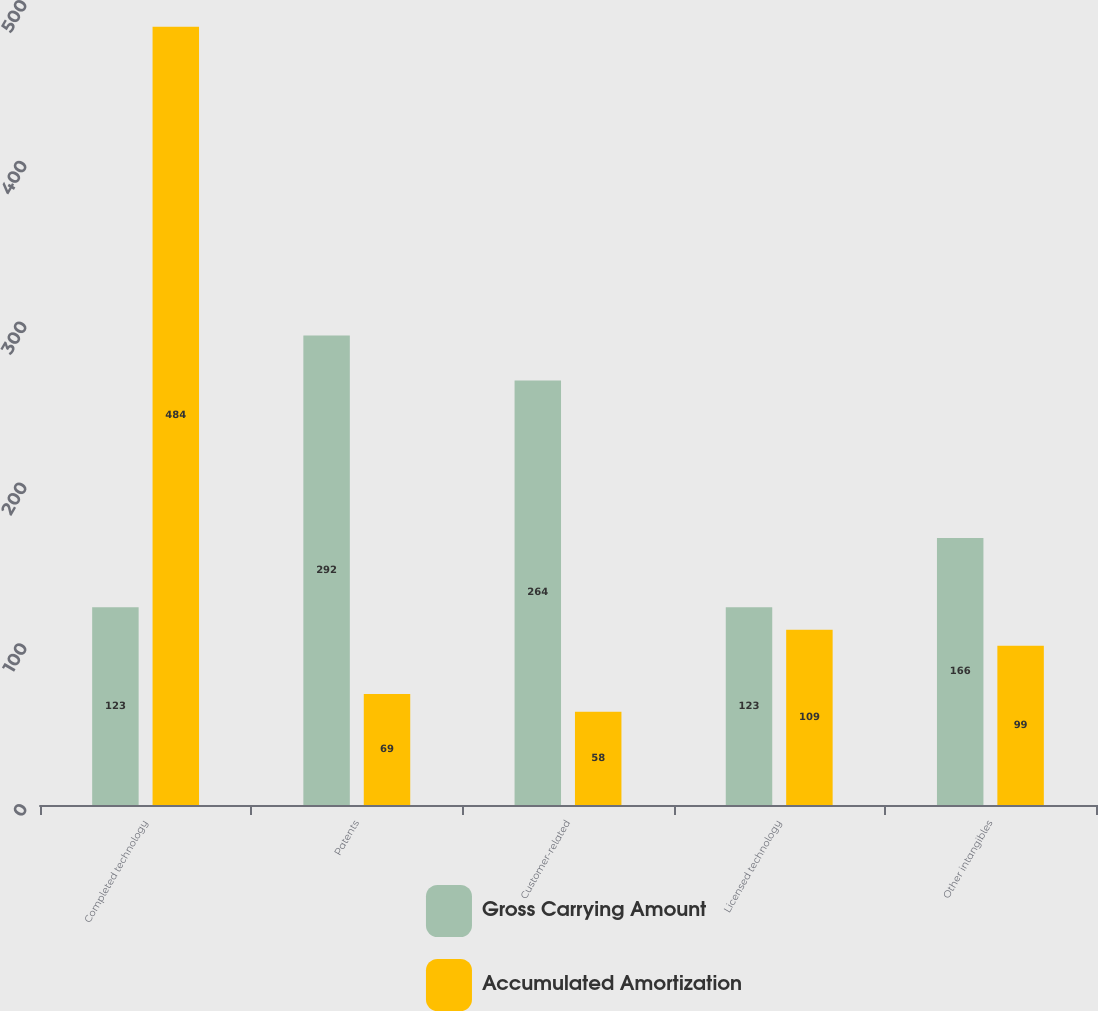Convert chart to OTSL. <chart><loc_0><loc_0><loc_500><loc_500><stacked_bar_chart><ecel><fcel>Completed technology<fcel>Patents<fcel>Customer-related<fcel>Licensed technology<fcel>Other intangibles<nl><fcel>Gross Carrying Amount<fcel>123<fcel>292<fcel>264<fcel>123<fcel>166<nl><fcel>Accumulated Amortization<fcel>484<fcel>69<fcel>58<fcel>109<fcel>99<nl></chart> 